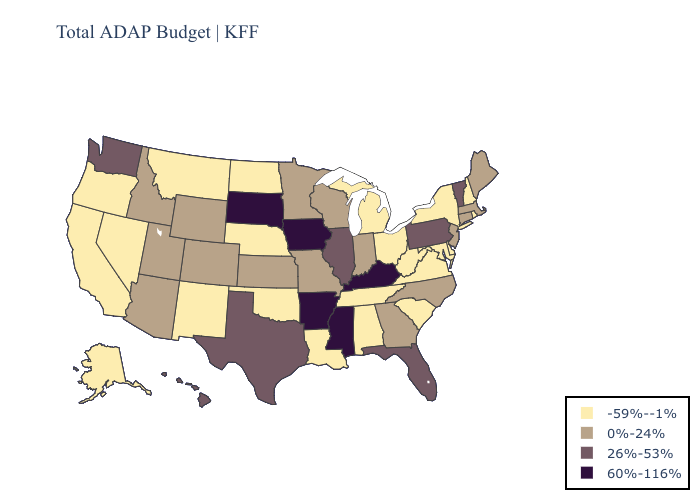Does Georgia have the same value as Colorado?
Be succinct. Yes. Does South Dakota have the lowest value in the USA?
Keep it brief. No. What is the highest value in the Northeast ?
Give a very brief answer. 26%-53%. Among the states that border Massachusetts , does Connecticut have the lowest value?
Short answer required. No. Name the states that have a value in the range 0%-24%?
Write a very short answer. Arizona, Colorado, Connecticut, Georgia, Idaho, Indiana, Kansas, Maine, Massachusetts, Minnesota, Missouri, New Jersey, North Carolina, Utah, Wisconsin, Wyoming. Does the map have missing data?
Quick response, please. No. Is the legend a continuous bar?
Write a very short answer. No. What is the value of California?
Answer briefly. -59%--1%. What is the highest value in the South ?
Write a very short answer. 60%-116%. Name the states that have a value in the range 0%-24%?
Short answer required. Arizona, Colorado, Connecticut, Georgia, Idaho, Indiana, Kansas, Maine, Massachusetts, Minnesota, Missouri, New Jersey, North Carolina, Utah, Wisconsin, Wyoming. Which states have the highest value in the USA?
Quick response, please. Arkansas, Iowa, Kentucky, Mississippi, South Dakota. Among the states that border Maine , which have the lowest value?
Answer briefly. New Hampshire. Is the legend a continuous bar?
Answer briefly. No. What is the lowest value in states that border Minnesota?
Quick response, please. -59%--1%. Does the map have missing data?
Short answer required. No. 